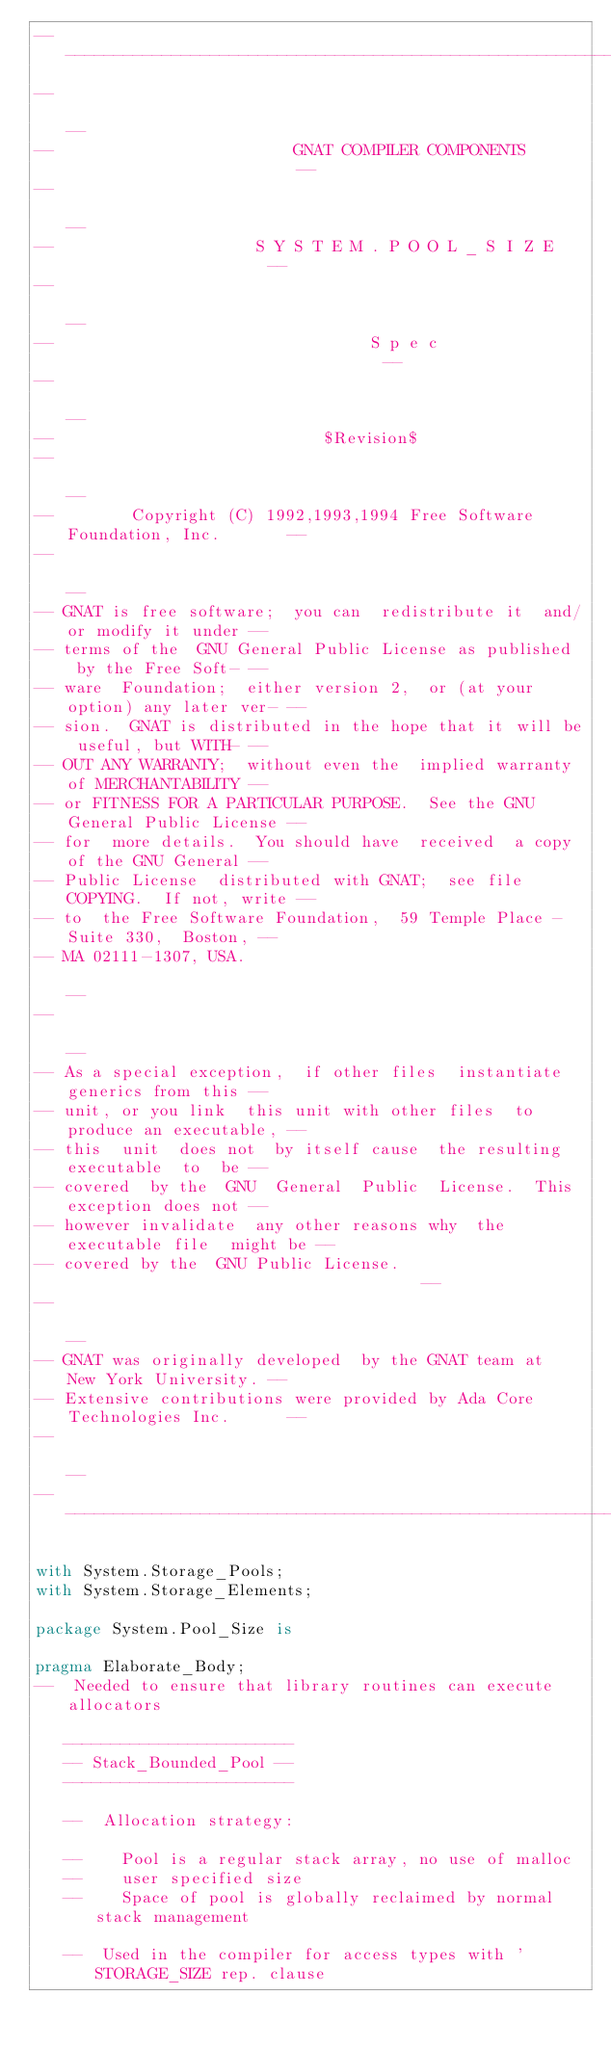Convert code to text. <code><loc_0><loc_0><loc_500><loc_500><_Ada_>------------------------------------------------------------------------------
--                                                                          --
--                         GNAT COMPILER COMPONENTS                         --
--                                                                          --
--                     S Y S T E M . P O O L _ S I Z E                      --
--                                                                          --
--                                 S p e c                                  --
--                                                                          --
--                            $Revision$
--                                                                          --
--        Copyright (C) 1992,1993,1994 Free Software Foundation, Inc.       --
--                                                                          --
-- GNAT is free software;  you can  redistribute it  and/or modify it under --
-- terms of the  GNU General Public License as published  by the Free Soft- --
-- ware  Foundation;  either version 2,  or (at your option) any later ver- --
-- sion.  GNAT is distributed in the hope that it will be useful, but WITH- --
-- OUT ANY WARRANTY;  without even the  implied warranty of MERCHANTABILITY --
-- or FITNESS FOR A PARTICULAR PURPOSE.  See the GNU General Public License --
-- for  more details.  You should have  received  a copy of the GNU General --
-- Public License  distributed with GNAT;  see file COPYING.  If not, write --
-- to  the Free Software Foundation,  59 Temple Place - Suite 330,  Boston, --
-- MA 02111-1307, USA.                                                      --
--                                                                          --
-- As a special exception,  if other files  instantiate  generics from this --
-- unit, or you link  this unit with other files  to produce an executable, --
-- this  unit  does not  by itself cause  the resulting  executable  to  be --
-- covered  by the  GNU  General  Public  License.  This exception does not --
-- however invalidate  any other reasons why  the executable file  might be --
-- covered by the  GNU Public License.                                      --
--                                                                          --
-- GNAT was originally developed  by the GNAT team at  New York University. --
-- Extensive contributions were provided by Ada Core Technologies Inc.      --
--                                                                          --
------------------------------------------------------------------------------

with System.Storage_Pools;
with System.Storage_Elements;

package System.Pool_Size is

pragma Elaborate_Body;
--  Needed to ensure that library routines can execute allocators

   ------------------------
   -- Stack_Bounded_Pool --
   ------------------------

   --  Allocation strategy:

   --    Pool is a regular stack array, no use of malloc
   --    user specified size
   --    Space of pool is globally reclaimed by normal stack management

   --  Used in the compiler for access types with 'STORAGE_SIZE rep. clause</code> 